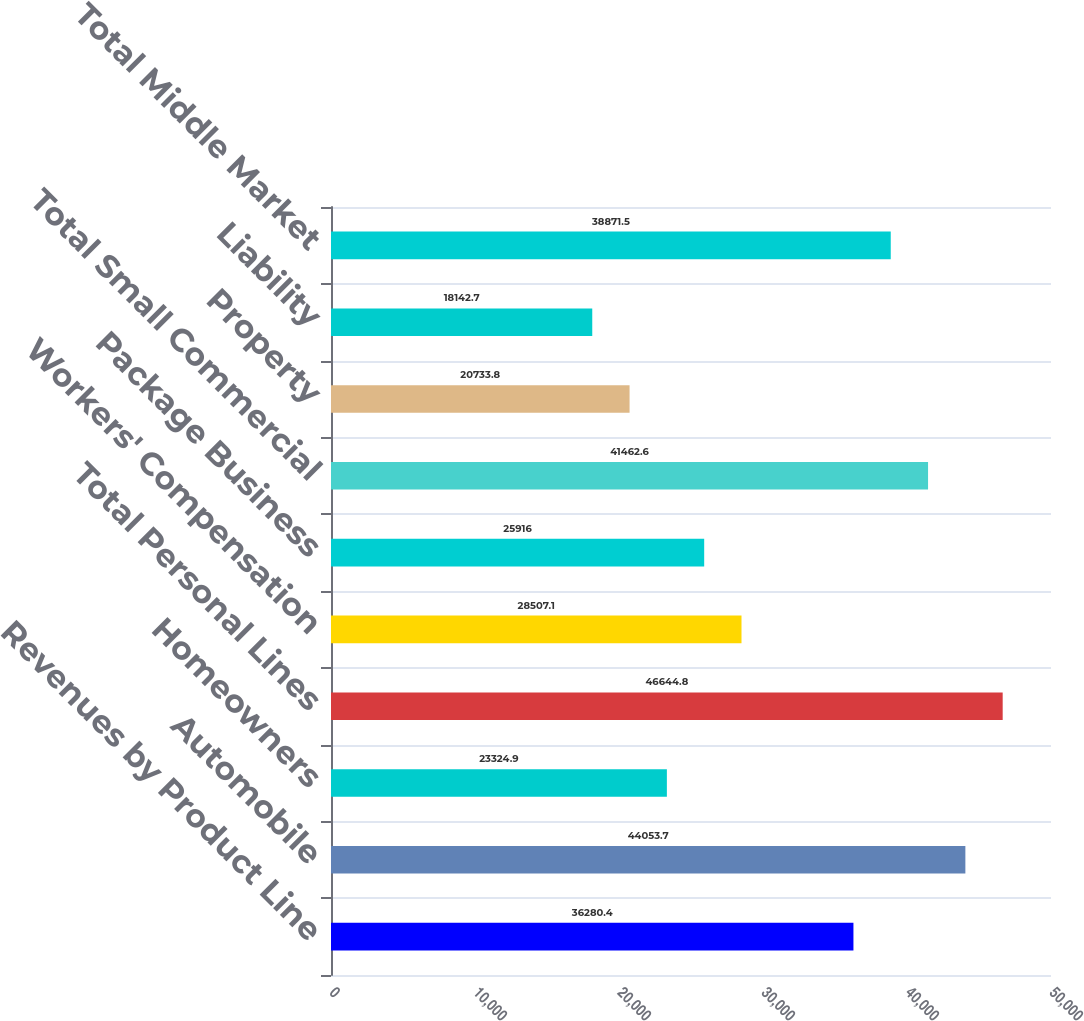Convert chart to OTSL. <chart><loc_0><loc_0><loc_500><loc_500><bar_chart><fcel>Revenues by Product Line<fcel>Automobile<fcel>Homeowners<fcel>Total Personal Lines<fcel>Workers' Compensation<fcel>Package Business<fcel>Total Small Commercial<fcel>Property<fcel>Liability<fcel>Total Middle Market<nl><fcel>36280.4<fcel>44053.7<fcel>23324.9<fcel>46644.8<fcel>28507.1<fcel>25916<fcel>41462.6<fcel>20733.8<fcel>18142.7<fcel>38871.5<nl></chart> 